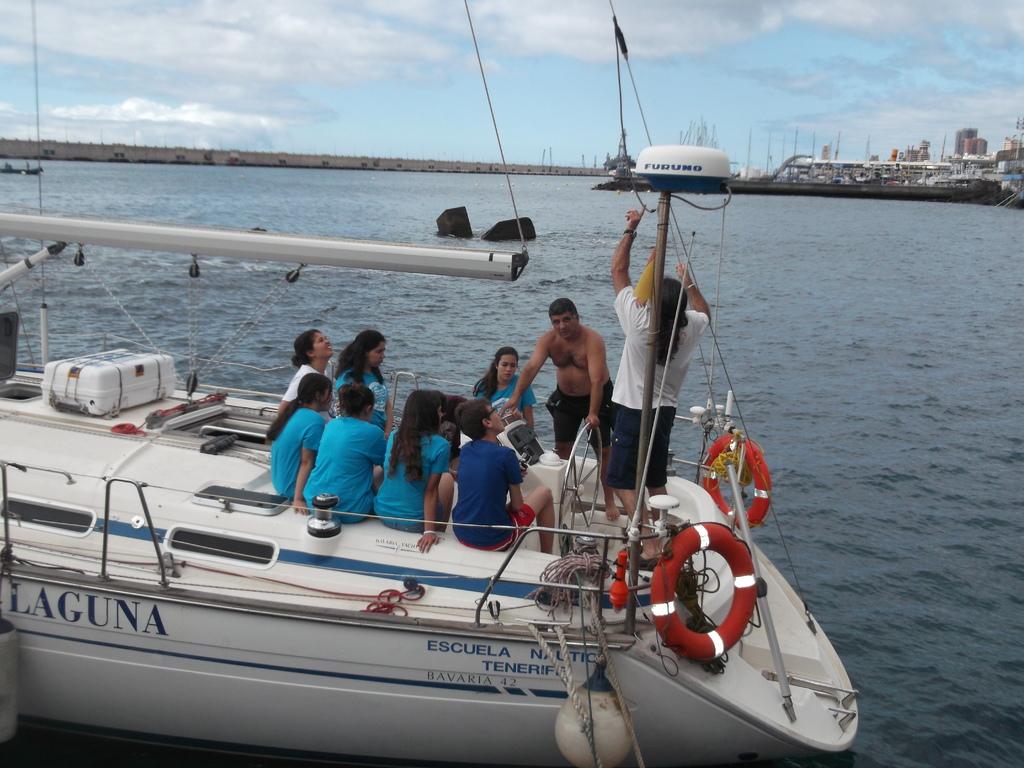What number is on the boat?
Provide a short and direct response. 42. What is the name on the side of the boat?
Your response must be concise. Laguna. 